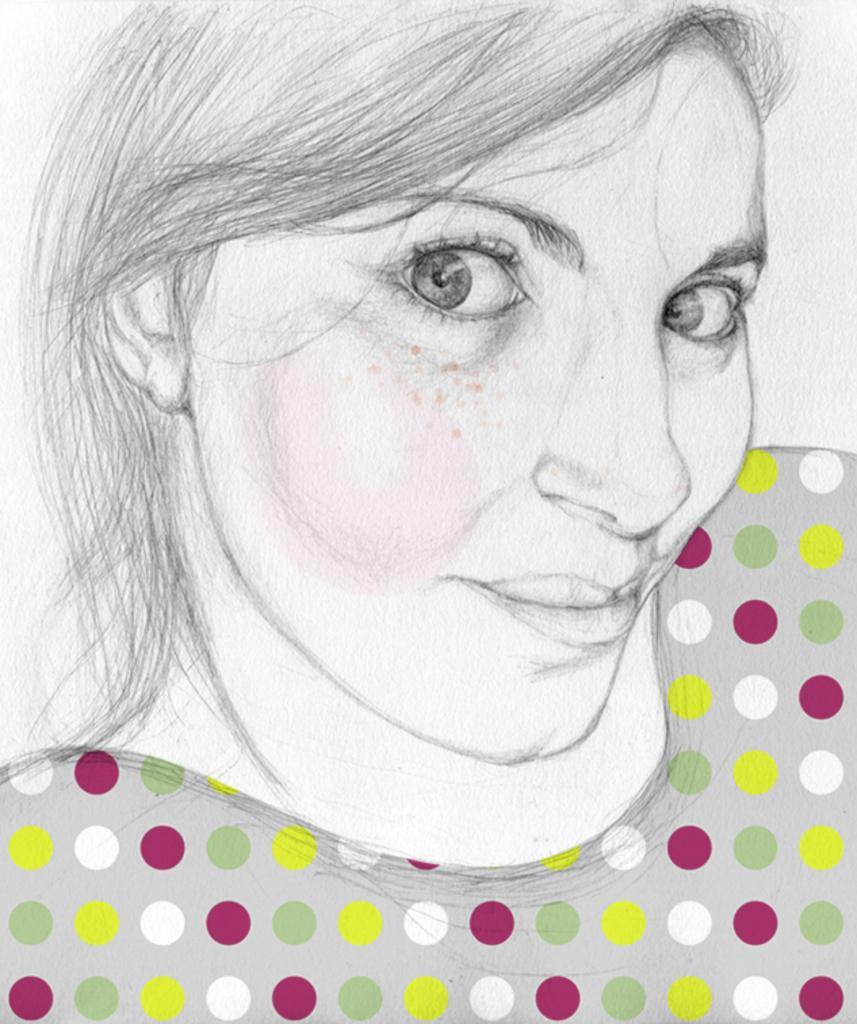How would you summarize this image in a sentence or two? As we can see in the image there is a rough pencil sketch of a woman and she is wearing a ash colour top with polka dots on it. The polka dots are in red, white, yellow and green colour. 